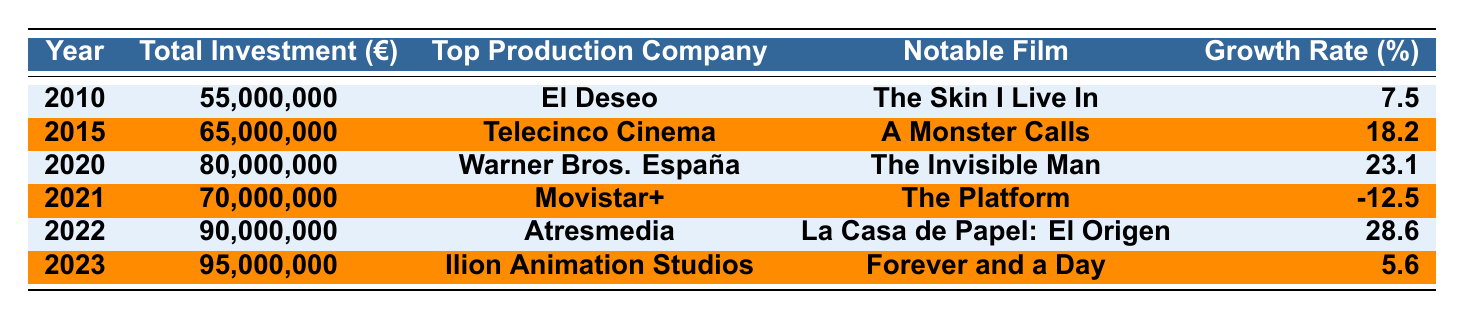What was the total investment in Spanish films in 2022? The table shows the total investment for 2022 as €90,000,000.
Answer: €90,000,000 Which production company was the top investor in 2020? The table indicates that the top production company in 2020 was Warner Bros. España.
Answer: Warner Bros. España What notable film was associated with Telecinco Cinema in 2015? According to the table, the notable film for Telecinco Cinema in 2015 was A Monster Calls.
Answer: A Monster Calls What was the total investment growth rate for Spanish films from 2010 to 2015? The growth rate from 2010 (€55,000,000) to 2015 (€65,000,000) can be calculated as ((65,000,000 - 55,000,000) / 55,000,000) * 100 = 18.18, which rounds to 18.2%.
Answer: 18.2% Was there an increase in total investment from 2021 to 2022? The total investment in 2021 was €70,000,000 and in 2022 it was €90,000,000; this shows an increase of €20,000,000, which confirms the statement is true.
Answer: Yes Calculate the average total investment over the years 2010, 2015, and 2020. The total investments for those years are €55,000,000 (2010), €65,000,000 (2015), and €80,000,000 (2020). Sum them: 55,000,000 + 65,000,000 + 80,000,000 = 200,000,000. Divide by 3 (the number of years): 200,000,000 / 3 = 66,666,667.
Answer: €66,666,667 Which year saw the highest growth rate in investment? Analyzing the growth rates in the table, the highest growth rate is from 2021 to 2022 at 28.6%.
Answer: 2022 How much total investment was noted in 2023 compared to 2020? The total investment in 2023 is €95,000,000 and in 2020 it was €80,000,000; thus, 2023 has an increase of €15,000,000 compared to 2020.
Answer: €15,000,000 increase Was there any year with a negative growth rate? Yes, according to the table, 2021 had a negative growth rate of -12.5%.
Answer: Yes What was the notable film for Atresmedia in 2022? The notable film for Atresmedia in 2022 was La Casa de Papel: El Origen, as mentioned in the table.
Answer: La Casa de Papel: El Origen 